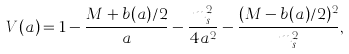Convert formula to latex. <formula><loc_0><loc_0><loc_500><loc_500>V ( a ) = 1 - \frac { M + b ( a ) / 2 } { a } - \frac { m _ { s } ^ { 2 } } { 4 a ^ { 2 } } - \frac { ( M - b ( a ) / 2 ) ^ { 2 } } { m _ { s } ^ { 2 } } ,</formula> 